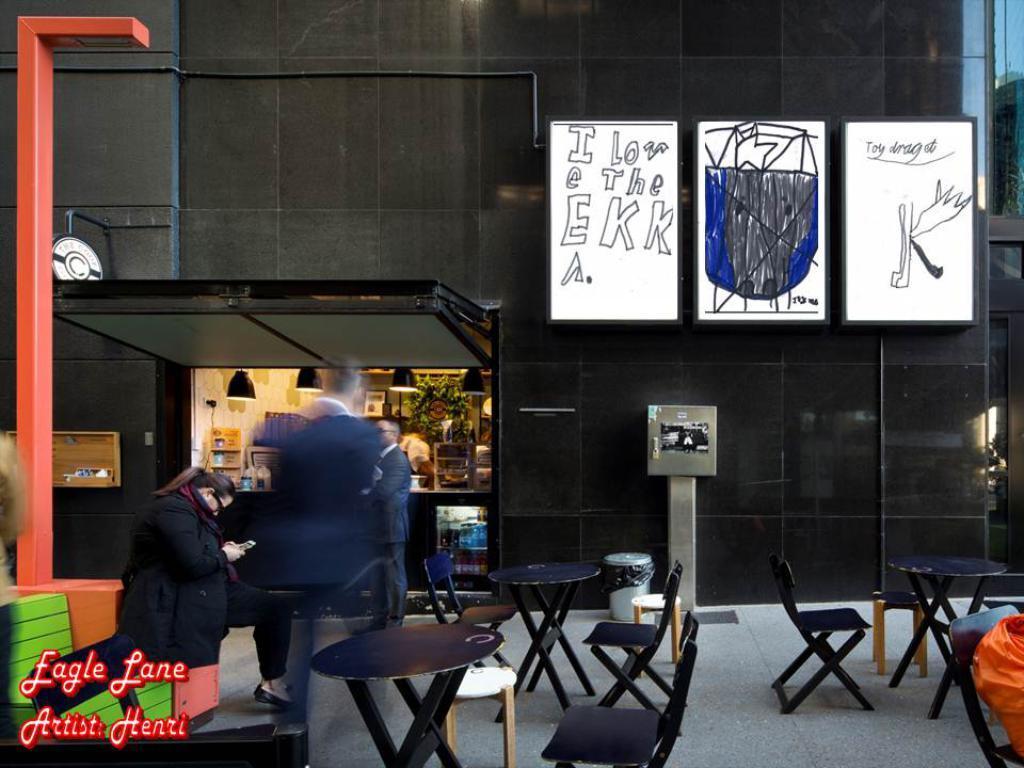How would you summarize this image in a sentence or two? In the image I can see a place in which there are some chairs, tables, whiteboards and also I can see a pole and some other things around. 